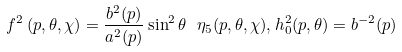<formula> <loc_0><loc_0><loc_500><loc_500>f ^ { 2 } \left ( p , \theta , \chi \right ) = \frac { b ^ { 2 } ( p ) } { a ^ { 2 } ( p ) } \sin ^ { 2 } \theta \ \eta _ { 5 } ( p , \theta , \chi ) , h _ { 0 } ^ { 2 } ( p , \theta ) = b ^ { - 2 } ( p )</formula> 